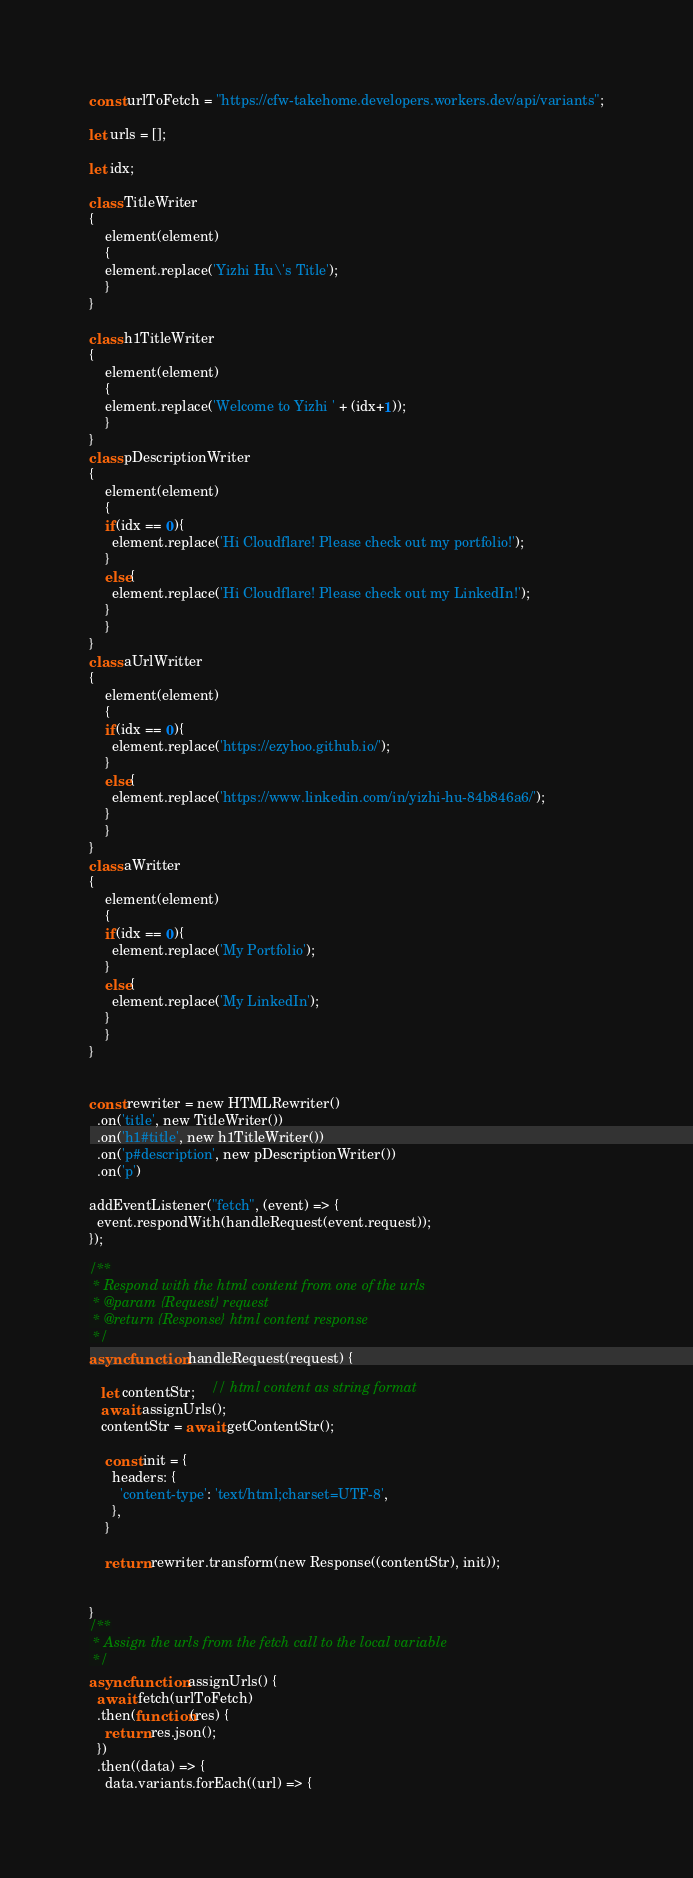<code> <loc_0><loc_0><loc_500><loc_500><_JavaScript_>const urlToFetch = "https://cfw-takehome.developers.workers.dev/api/variants";

let urls = [];

let idx;

class TitleWriter
{
	element(element)
	{
    element.replace('Yizhi Hu\'s Title');
	}
}

class h1TitleWriter
{
	element(element)
	{
    element.replace('Welcome to Yizhi ' + (idx+1));
	}
}
class pDescriptionWriter
{
	element(element)
	{
    if(idx == 0){
      element.replace('Hi Cloudflare! Please check out my portfolio!');
    }
    else{
      element.replace('Hi Cloudflare! Please check out my LinkedIn!');
    }
	}
}
class aUrlWritter
{
	element(element)
	{
    if(idx == 0){
      element.replace('https://ezyhoo.github.io/');
    }
    else{
      element.replace('https://www.linkedin.com/in/yizhi-hu-84b846a6/');
    }
	}
}
class aWritter
{
	element(element)
	{
    if(idx == 0){
      element.replace('My Portfolio');
    }
    else{
      element.replace('My LinkedIn');
    }
	}
}


const rewriter = new HTMLRewriter()
  .on('title', new TitleWriter())
  .on('h1#title', new h1TitleWriter())
  .on('p#description', new pDescriptionWriter())
  .on('p')

addEventListener("fetch", (event) => {
  event.respondWith(handleRequest(event.request));
});

/**
 * Respond with the html content from one of the urls
 * @param {Request} request
 * @return {Response} html content response
 */
async function handleRequest(request) {

   let contentStr;    // html content as string format
   await assignUrls();
   contentStr = await getContentStr();

    const init = {
      headers: {
        'content-type': 'text/html;charset=UTF-8',
      },
    }

    return rewriter.transform(new Response((contentStr), init));


}
/**
 * Assign the urls from the fetch call to the local variable
 */
async function assignUrls() {
  await fetch(urlToFetch)
  .then(function(res) {
    return res.json();
  })
  .then((data) => {
    data.variants.forEach((url) => {</code> 